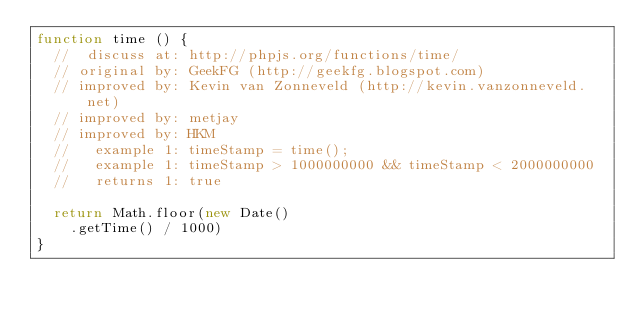Convert code to text. <code><loc_0><loc_0><loc_500><loc_500><_JavaScript_>function time () {
  //  discuss at: http://phpjs.org/functions/time/
  // original by: GeekFG (http://geekfg.blogspot.com)
  // improved by: Kevin van Zonneveld (http://kevin.vanzonneveld.net)
  // improved by: metjay
  // improved by: HKM
  //   example 1: timeStamp = time();
  //   example 1: timeStamp > 1000000000 && timeStamp < 2000000000
  //   returns 1: true

  return Math.floor(new Date()
    .getTime() / 1000)
}
</code> 